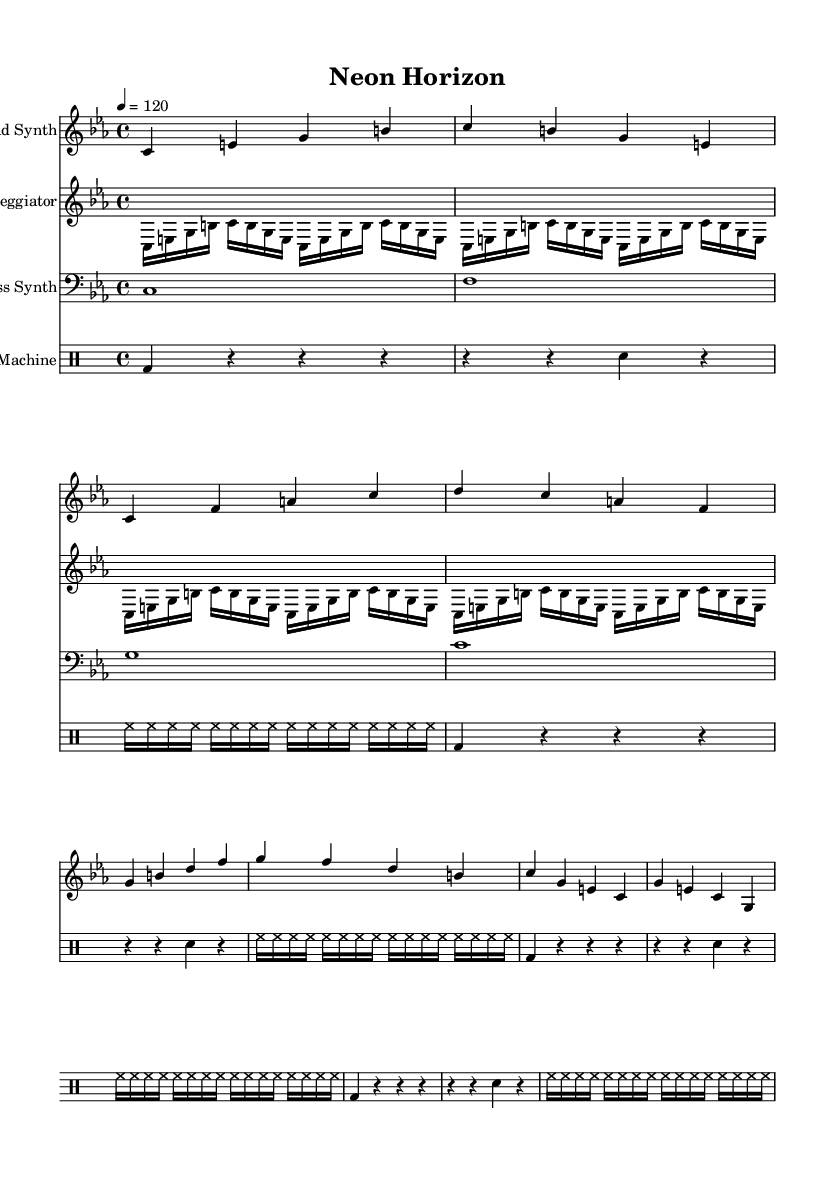What is the key signature of this music? The key signature is C minor, which has three flats (B-flat, E-flat, A-flat) in the key signature indicated at the beginning of the score.
Answer: C minor What is the time signature of this music? The time signature is 4/4, which signifies that there are four beats in each measure and a quarter note gets one beat, as shown at the beginning of the staff.
Answer: 4/4 What is the tempo marking for this piece? The tempo marking is 120 BPM (beats per minute), indicated in quarter note equals 120, which sets the speed of the piece at a moderate pace.
Answer: 120 How many measures does the lead synth part contain? The lead synth part contains 8 measures, which can be counted from the beginning of the music until the end of the section for lead synth.
Answer: 8 measures What type of rhythm is primarily used by the bass synth? The bass synth uses whole notes, which are indicated in a single note per measure for four measures, characteristic of a steady foundational rhythm.
Answer: Whole notes How does the arpeggiator synth contribute to the texture of the piece? The arpeggiator synth provides a continuous flow of sixteenth notes, creating a layered and textured sound against the sustained notes, enhancing the rhythmic drive of the music.
Answer: Continuous flow of sixteenth notes What is the function of the drum machine in this score? The drum machine provides a rhythmic foundation and drive, utilizing bass drum, snare, and hi-hat patterns that create a dynamic and pulse within the music, typical in synth-heavy electronic scores.
Answer: Rhythmic foundation and drive 